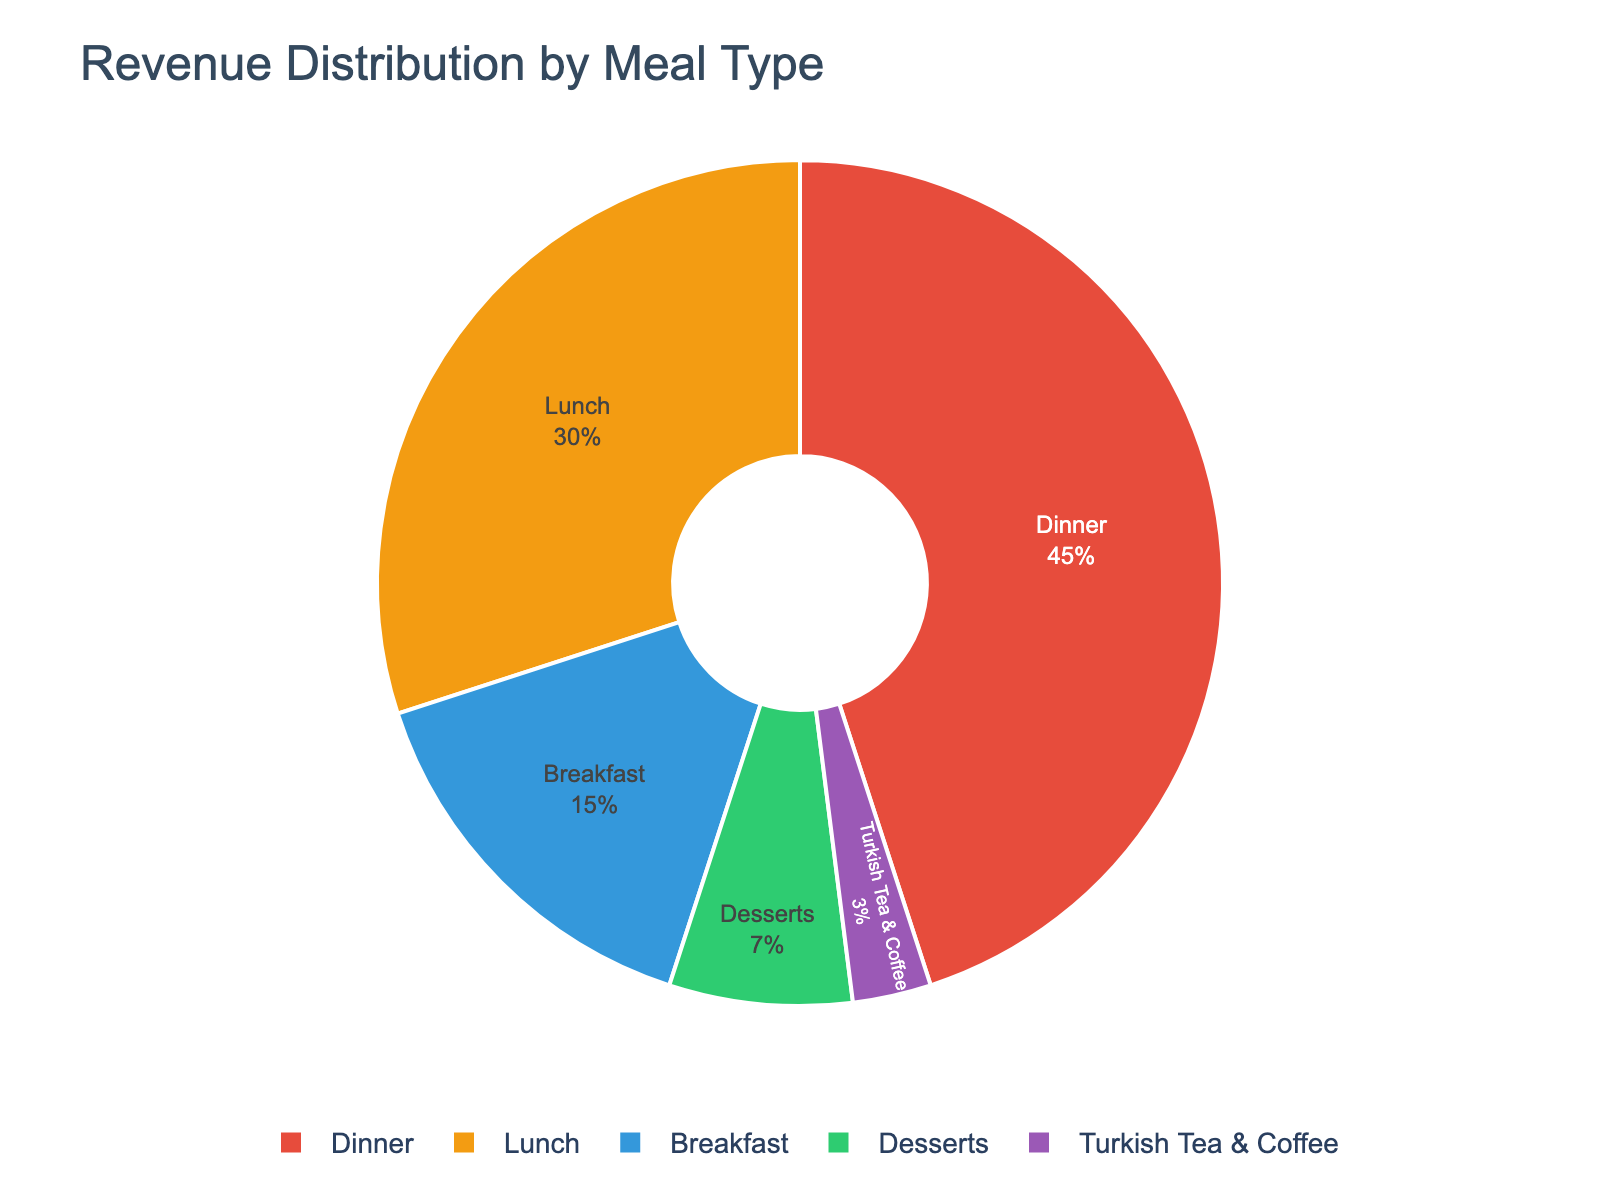What meal type generates the highest revenue? The highest revenue segment takes up the largest portion of the pie chart. "Dinner" occupies 45% which is the largest portion.
Answer: Dinner How much more revenue does lunch generate compared to desserts? Subtract the revenue percentage of desserts (7%) from the revenue percentage of lunch (30%). 30% - 7% = 23%
Answer: 23% What is the total revenue percentage generated by breakfast and desserts combined? Add the revenue percentages of breakfast (15%) and desserts (7%). 15% + 7% = 22%
Answer: 22% Which meal type generates the least revenue? The smallest segment of the pie chart represents the least revenue. "Turkish Tea & Coffee" is the smallest, with 3%.
Answer: Turkish Tea & Coffee Is the revenue from lunch less than the revenue from dinner? Compare the revenue percentages. Lunch is 30% and dinner is 45%. 30% is less than 45%.
Answer: Yes What is the combined revenue percentage of dinner and lunch? Add the revenue percentages of dinner (45%) and lunch (30%). 45% + 30% = 75%
Answer: 75% What is the difference in revenue percentage between breakfast and Turkish Tea & Coffee? Subtract the revenue percentage of Turkish Tea & Coffee (3%) from the revenue percentage of breakfast (15%). 15% - 3% = 12%
Answer: 12% How does the revenue from desserts compare to breakfast? Compare the revenue percentages: breakfast is 15% and desserts are 7%. 15% is greater than 7%.
Answer: Breakfast generates more revenue What is the combined revenue percentage of desserts, Turkish Tea & Coffee, and breakfast? Add the revenue percentages of desserts (7%), Turkish Tea & Coffee (3%), and breakfast (15%). 7% + 3% + 15% = 25%
Answer: 25% What meal types generate more than 20% of the revenue? Identify the segments that are greater than 20%. Only dinner (45%) and lunch (30%) are above 20%.
Answer: Dinner and Lunch 